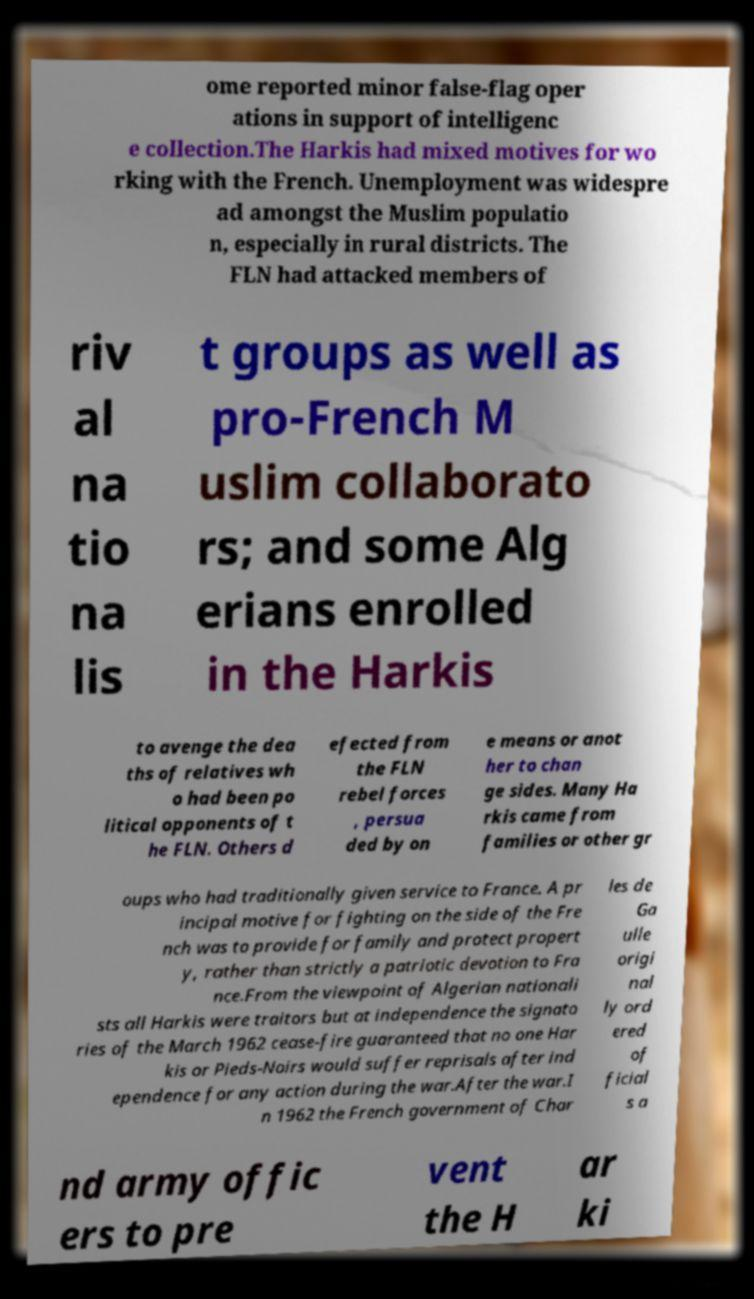I need the written content from this picture converted into text. Can you do that? ome reported minor false-flag oper ations in support of intelligenc e collection.The Harkis had mixed motives for wo rking with the French. Unemployment was widespre ad amongst the Muslim populatio n, especially in rural districts. The FLN had attacked members of riv al na tio na lis t groups as well as pro-French M uslim collaborato rs; and some Alg erians enrolled in the Harkis to avenge the dea ths of relatives wh o had been po litical opponents of t he FLN. Others d efected from the FLN rebel forces , persua ded by on e means or anot her to chan ge sides. Many Ha rkis came from families or other gr oups who had traditionally given service to France. A pr incipal motive for fighting on the side of the Fre nch was to provide for family and protect propert y, rather than strictly a patriotic devotion to Fra nce.From the viewpoint of Algerian nationali sts all Harkis were traitors but at independence the signato ries of the March 1962 cease-fire guaranteed that no one Har kis or Pieds-Noirs would suffer reprisals after ind ependence for any action during the war.After the war.I n 1962 the French government of Char les de Ga ulle origi nal ly ord ered of ficial s a nd army offic ers to pre vent the H ar ki 